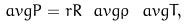<formula> <loc_0><loc_0><loc_500><loc_500>\ a v g { P } = r R \ a v g { \rho } \ a v g { T } ,</formula> 